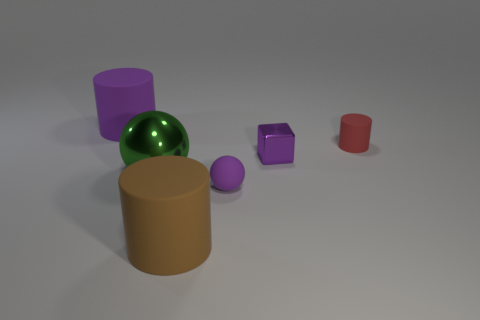Subtract all big cylinders. How many cylinders are left? 1 Subtract all red cylinders. How many cylinders are left? 2 Add 3 large yellow metallic objects. How many objects exist? 9 Subtract 1 cubes. How many cubes are left? 0 Subtract all cubes. How many objects are left? 5 Subtract 0 green cylinders. How many objects are left? 6 Subtract all gray blocks. Subtract all green cylinders. How many blocks are left? 1 Subtract all blue balls. How many purple cylinders are left? 1 Subtract all big cyan cubes. Subtract all big matte cylinders. How many objects are left? 4 Add 5 small red cylinders. How many small red cylinders are left? 6 